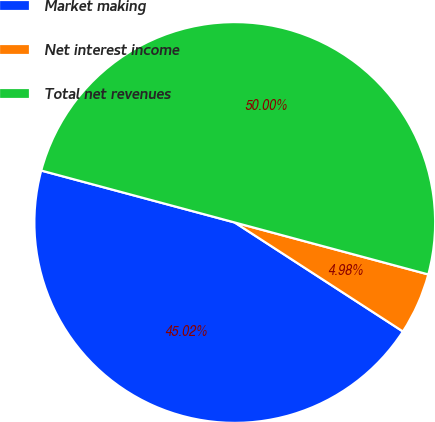Convert chart to OTSL. <chart><loc_0><loc_0><loc_500><loc_500><pie_chart><fcel>Market making<fcel>Net interest income<fcel>Total net revenues<nl><fcel>45.02%<fcel>4.98%<fcel>50.0%<nl></chart> 